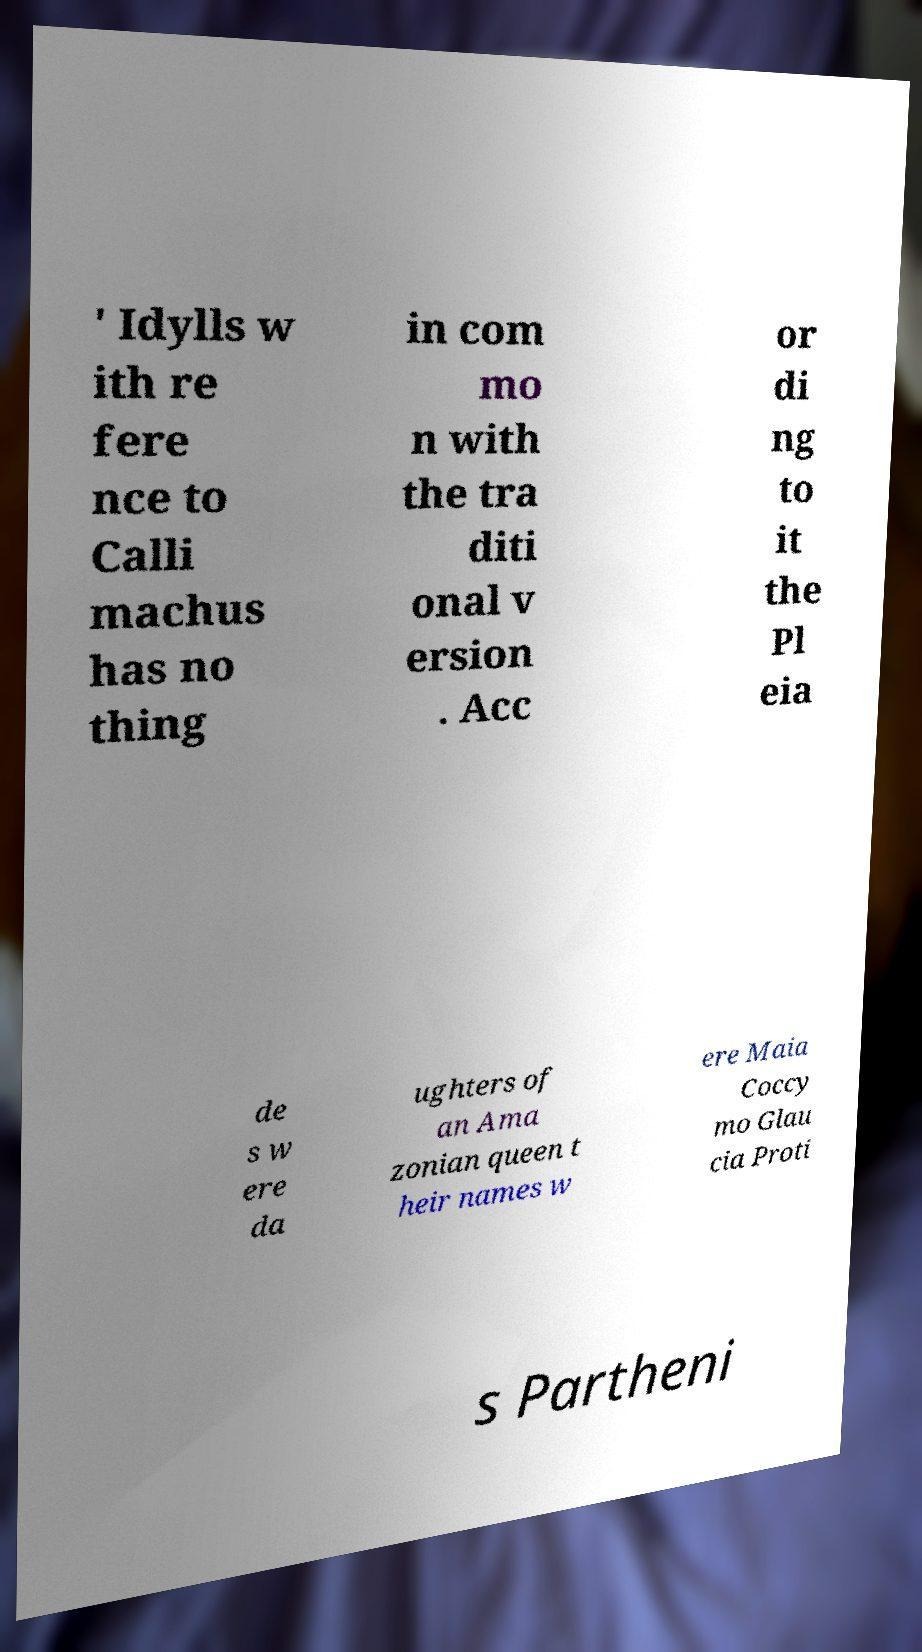Can you accurately transcribe the text from the provided image for me? ' Idylls w ith re fere nce to Calli machus has no thing in com mo n with the tra diti onal v ersion . Acc or di ng to it the Pl eia de s w ere da ughters of an Ama zonian queen t heir names w ere Maia Coccy mo Glau cia Proti s Partheni 